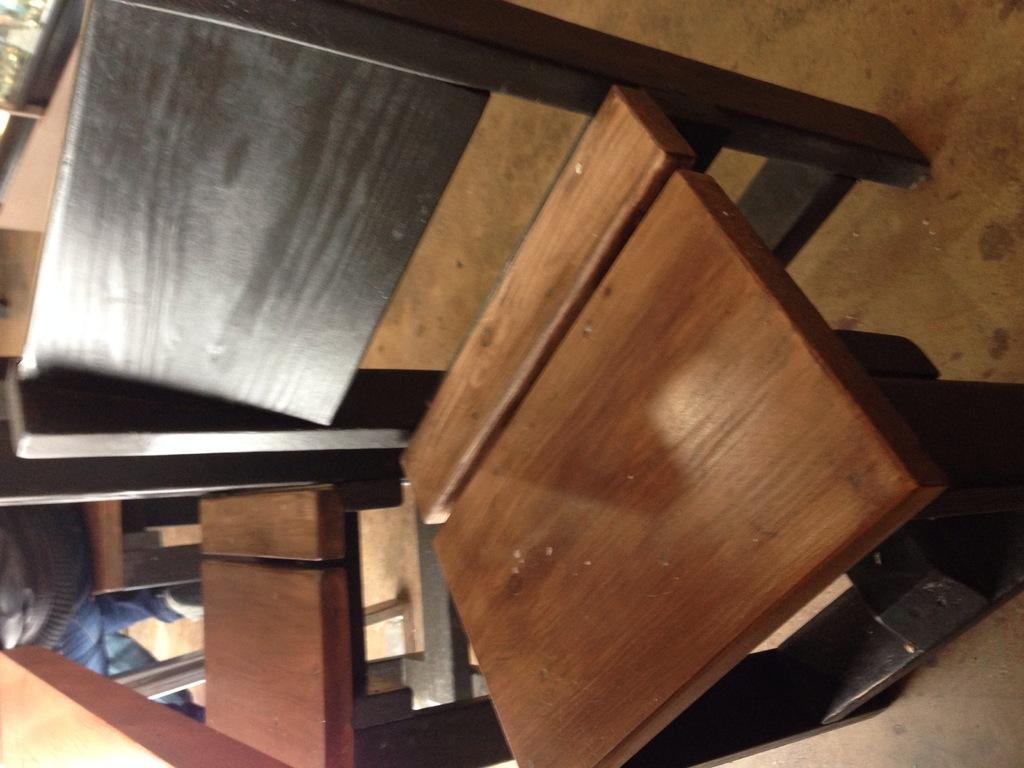What type of chairs are in the image? There are wooden chairs in the image. Can you describe the person visible in the background of the image? Unfortunately, the facts provided do not give enough information to describe the person in the background. What other objects can be seen in the background of the image? The facts provided do not specify any other objects in the background. What type of milk is being used to wash the spade in the image? There is no milk, washing, or spade present in the image. 